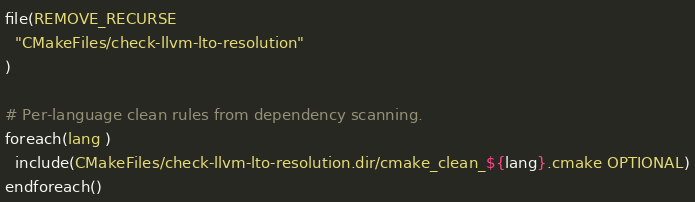<code> <loc_0><loc_0><loc_500><loc_500><_CMake_>file(REMOVE_RECURSE
  "CMakeFiles/check-llvm-lto-resolution"
)

# Per-language clean rules from dependency scanning.
foreach(lang )
  include(CMakeFiles/check-llvm-lto-resolution.dir/cmake_clean_${lang}.cmake OPTIONAL)
endforeach()
</code> 